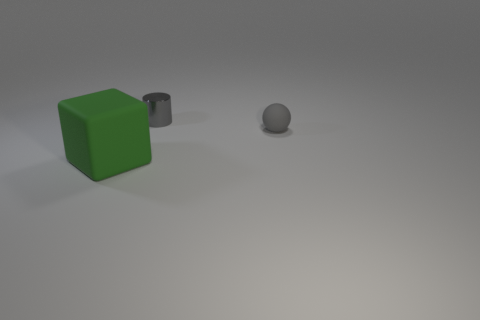Is there another thing of the same size as the gray matte thing?
Provide a short and direct response. Yes. How many things are big green rubber objects or small shiny cylinders?
Your response must be concise. 2. There is a rubber thing right of the green matte cube; is it the same size as the gray thing left of the tiny sphere?
Your answer should be compact. Yes. Is there another gray rubber object of the same shape as the small gray matte object?
Make the answer very short. No. Are there fewer gray balls to the right of the tiny gray rubber ball than matte cubes?
Make the answer very short. Yes. Is the big object the same shape as the tiny gray metallic thing?
Provide a short and direct response. No. How big is the rubber object that is right of the large green rubber block?
Your response must be concise. Small. There is a gray ball that is made of the same material as the green cube; what size is it?
Make the answer very short. Small. Is the number of large yellow balls less than the number of rubber objects?
Keep it short and to the point. Yes. There is a gray ball that is the same size as the gray metal cylinder; what material is it?
Keep it short and to the point. Rubber. 